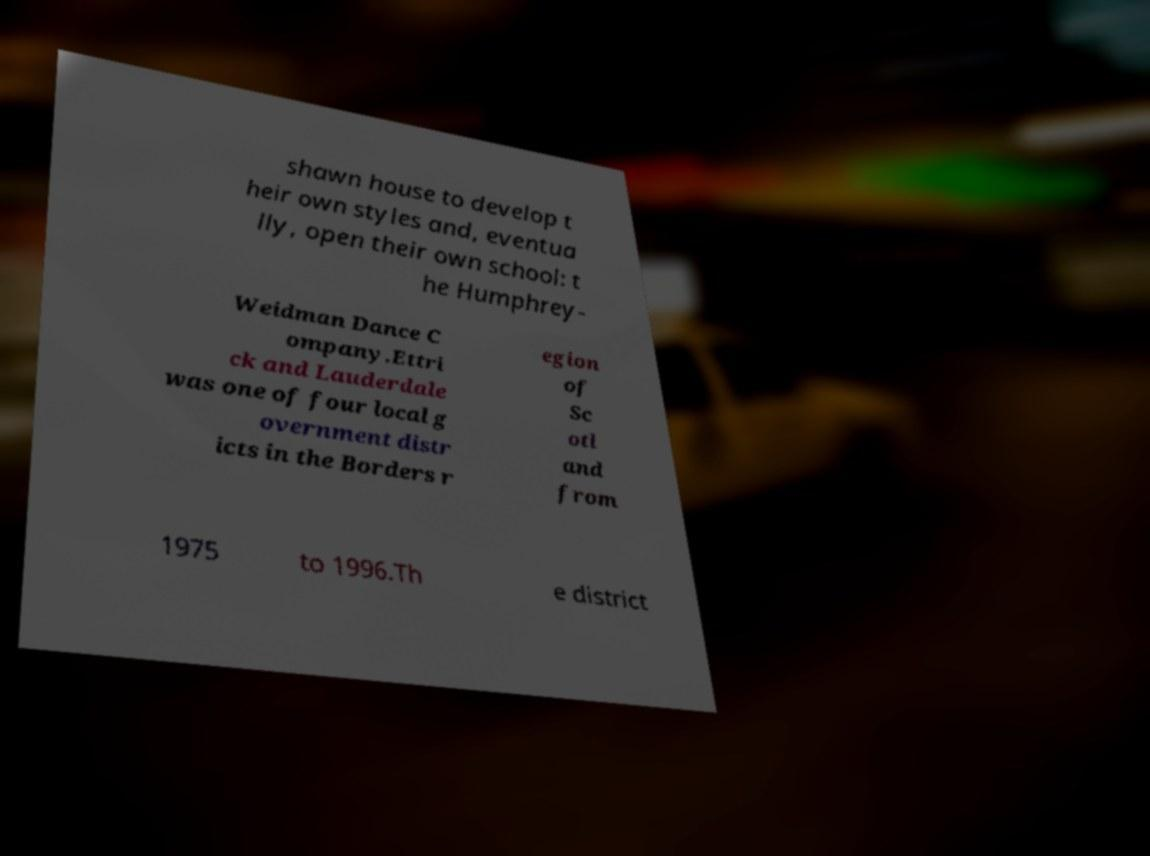Please read and relay the text visible in this image. What does it say? shawn house to develop t heir own styles and, eventua lly, open their own school: t he Humphrey- Weidman Dance C ompany.Ettri ck and Lauderdale was one of four local g overnment distr icts in the Borders r egion of Sc otl and from 1975 to 1996.Th e district 